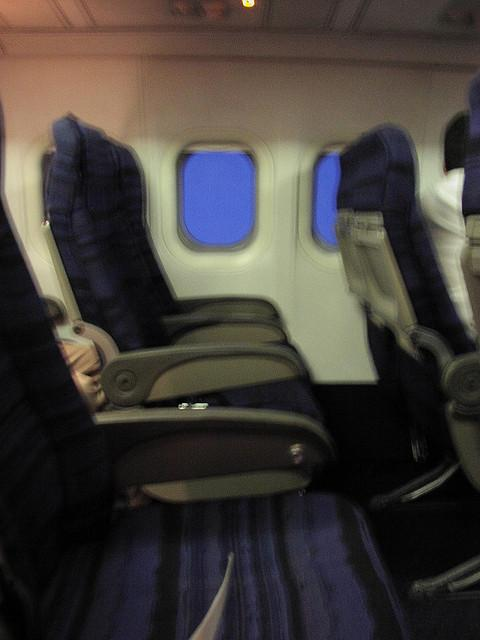Where are the seats placed inside? airplane 